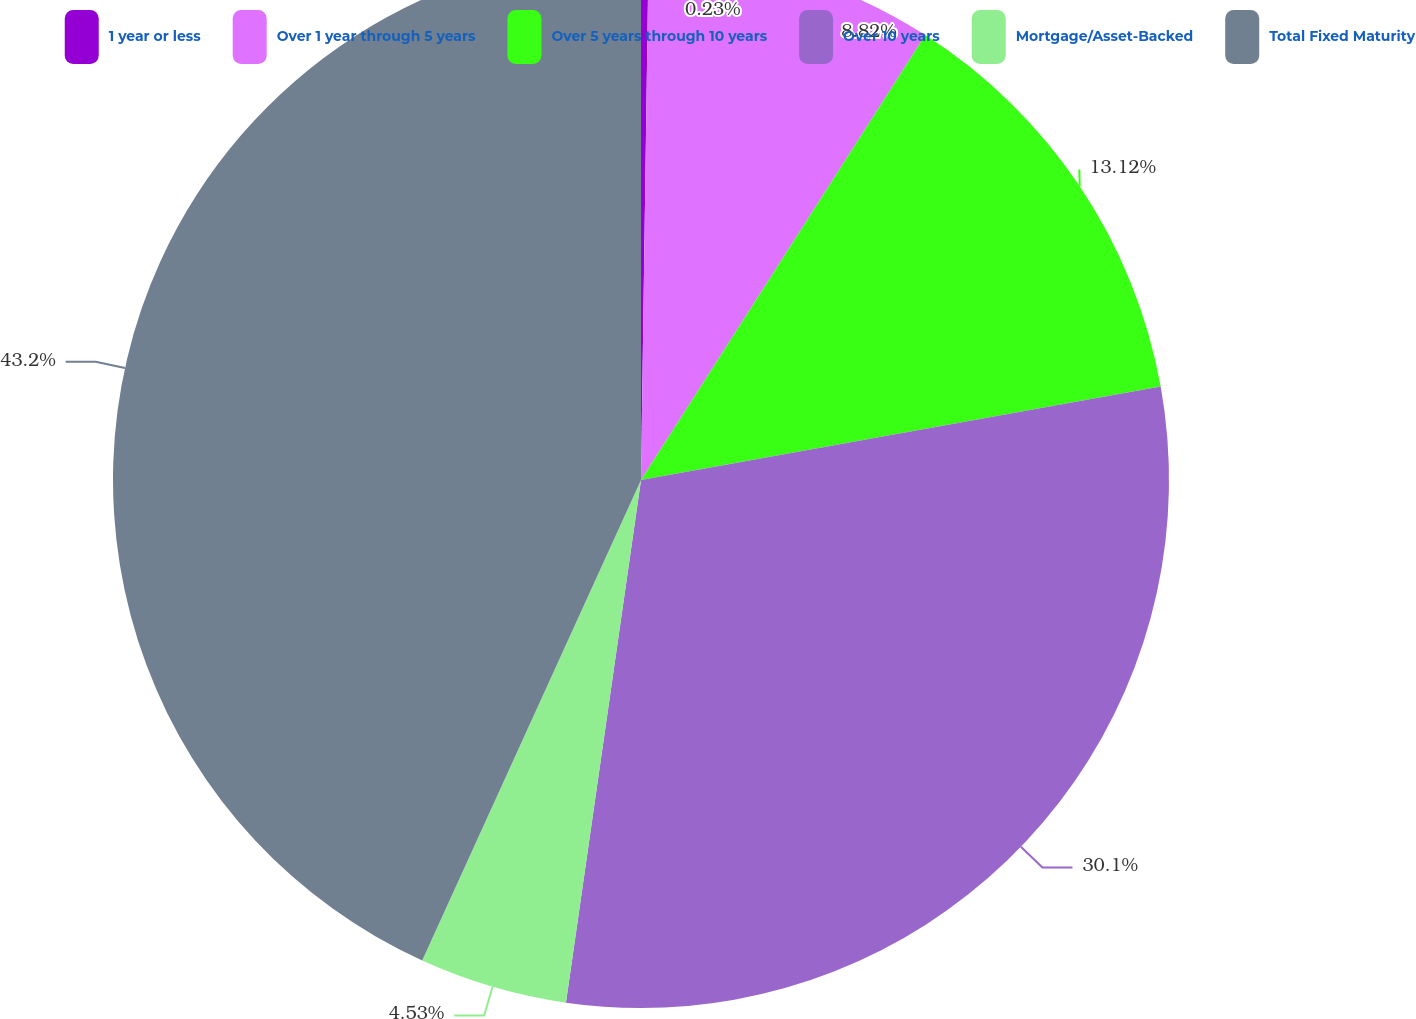<chart> <loc_0><loc_0><loc_500><loc_500><pie_chart><fcel>1 year or less<fcel>Over 1 year through 5 years<fcel>Over 5 years through 10 years<fcel>Over 10 years<fcel>Mortgage/Asset-Backed<fcel>Total Fixed Maturity<nl><fcel>0.23%<fcel>8.82%<fcel>13.12%<fcel>30.1%<fcel>4.53%<fcel>43.2%<nl></chart> 